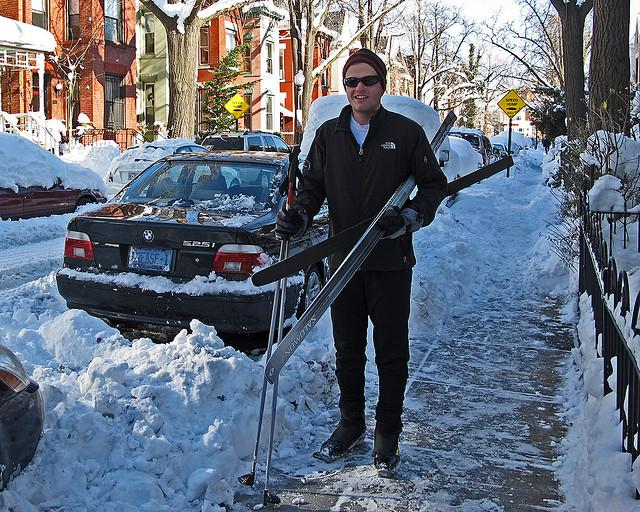How did this man get to this location immediately prior to taking this picture? Please explain your reasoning. walked. He is standing on a sidewalk, which means he walked and it's too snow covered to safely jog. 